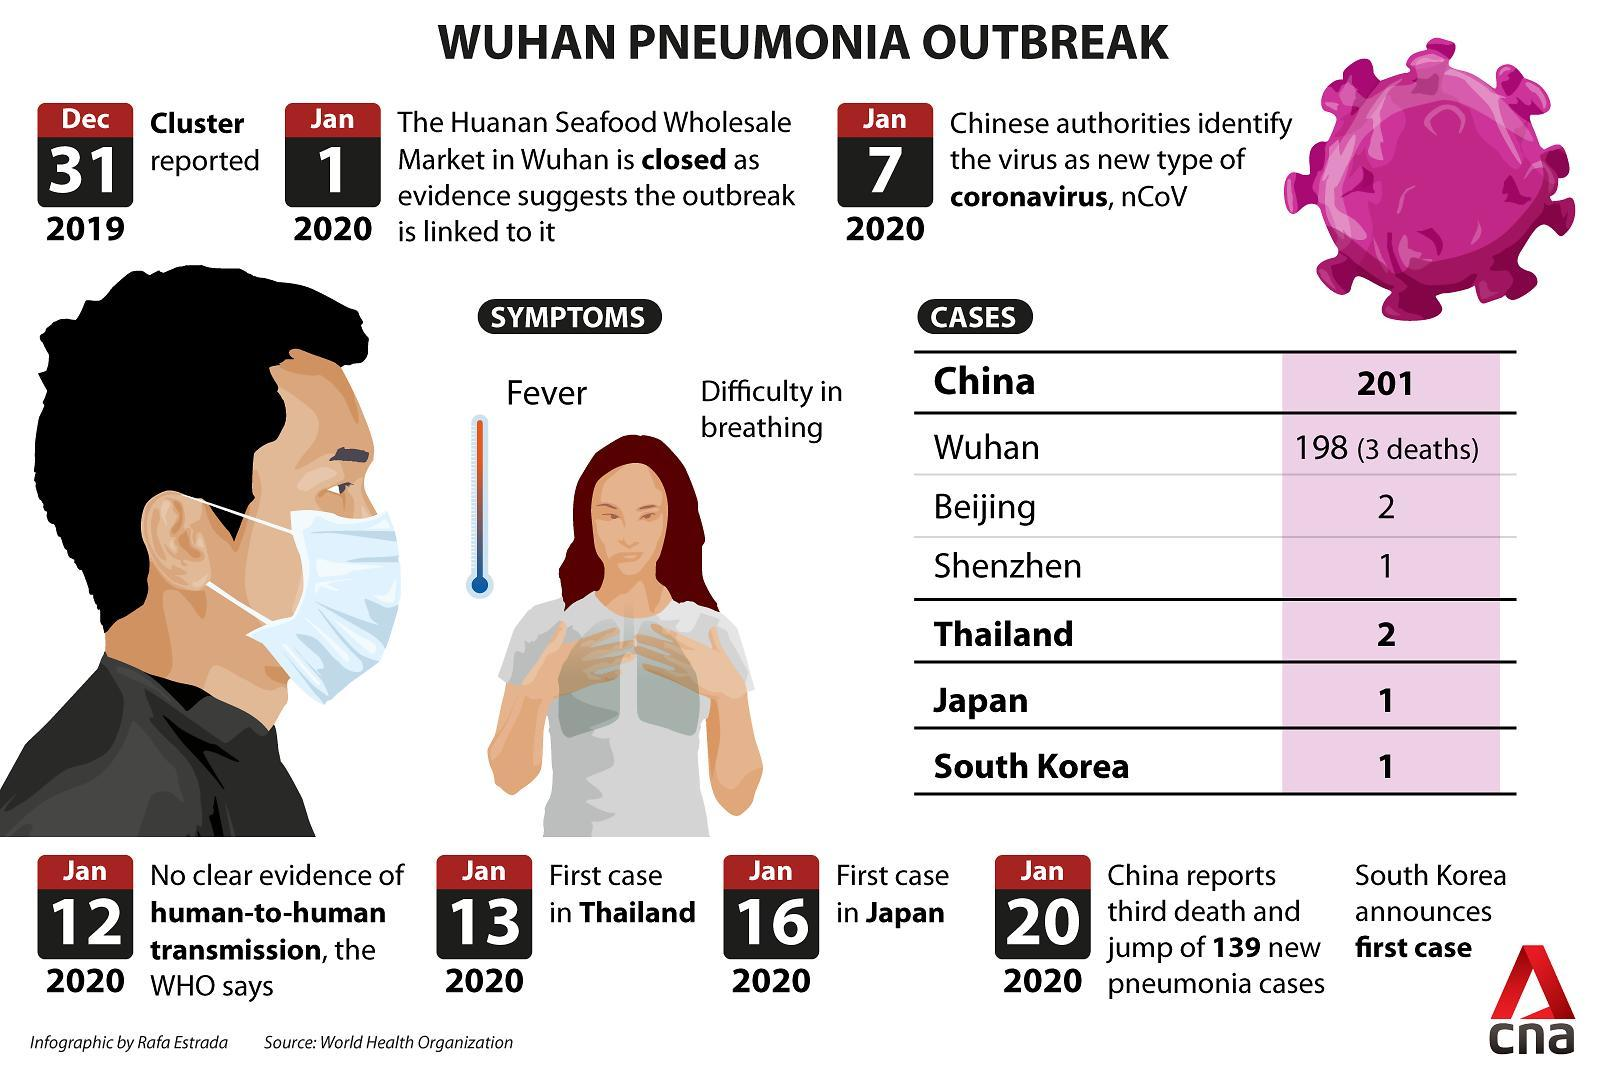How many coronavirus cases were reported in China as of January 2020?
Answer the question with a short phrase. 201 When was the first case of coronavirus detected in Japan? Jan 16 2020 When was the first case of coronavirus detected in South Korea? Jan 20 2020 What are the symptoms of Pneumonia? Fever, Difficulty in breathing How many deaths due to pneumonia were reported in Wuhan in January 2020? 3 